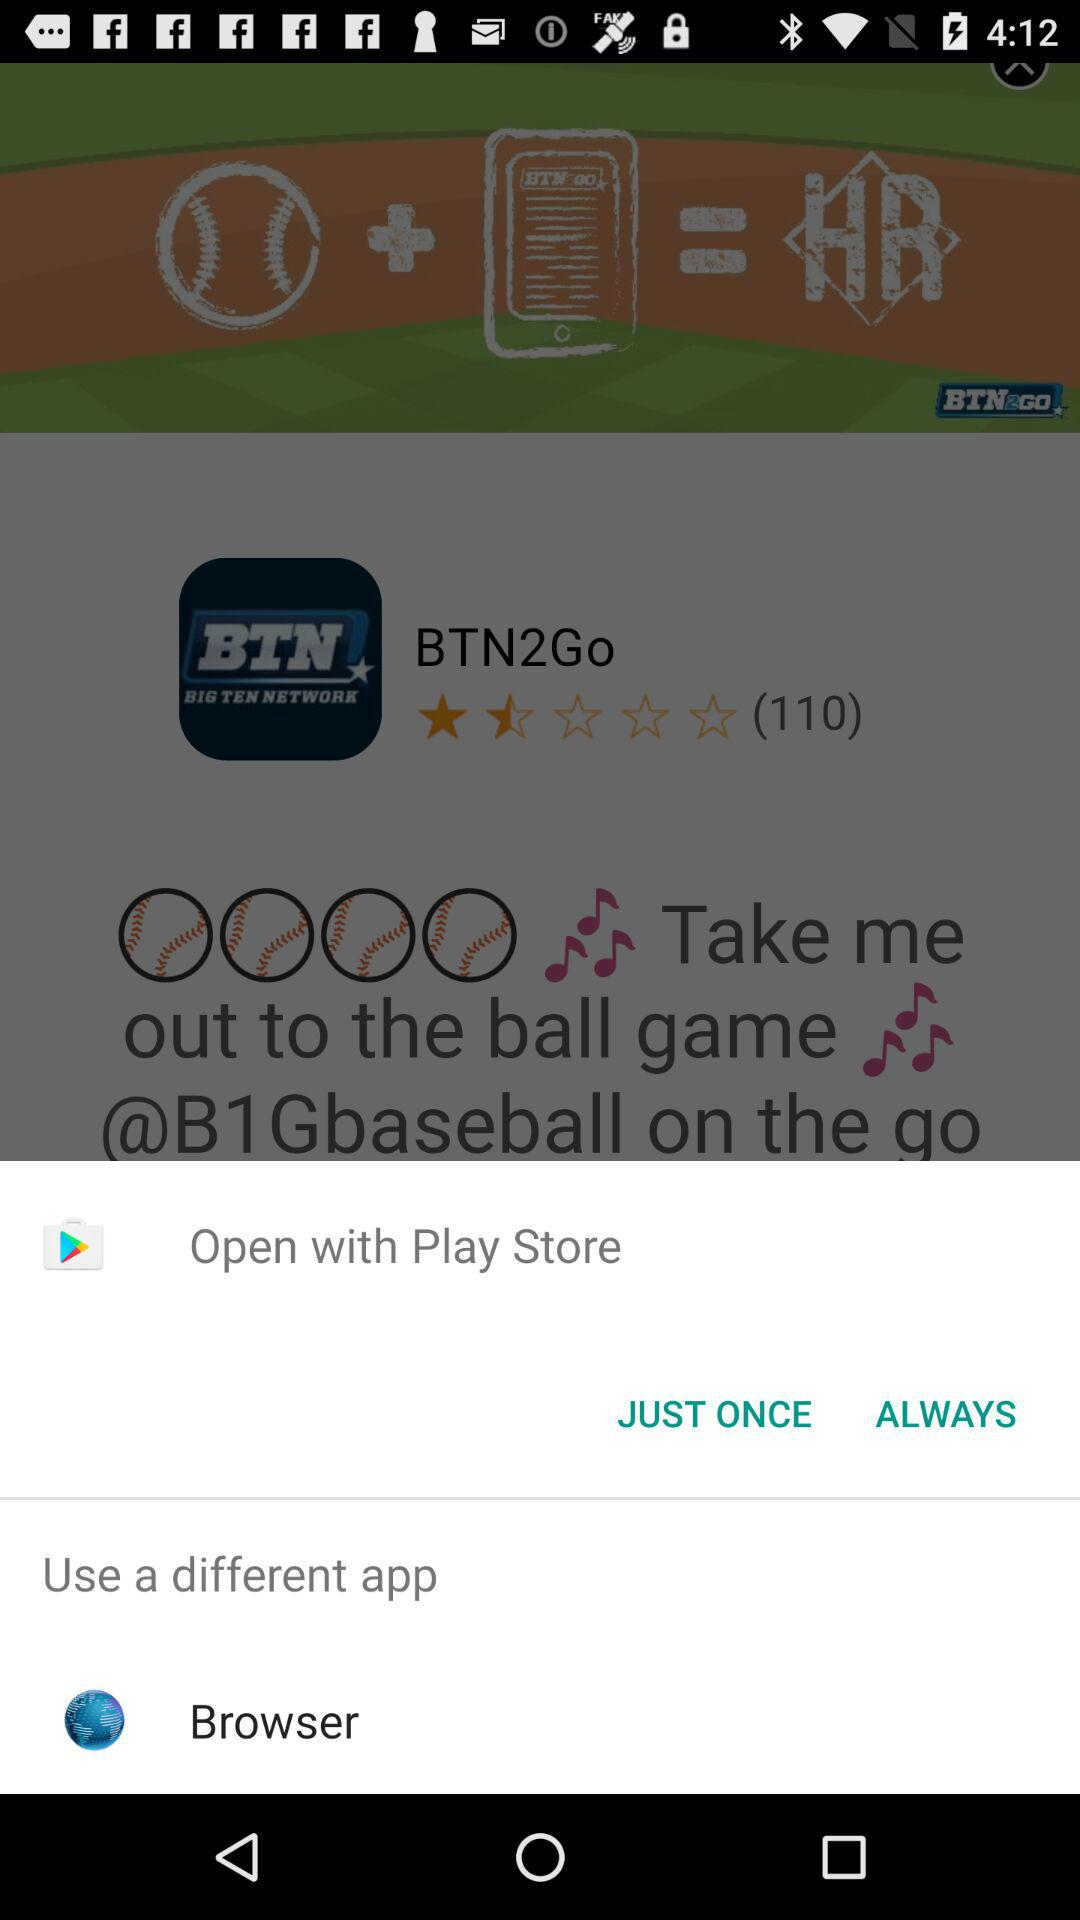What different app can I use? The different app that you can use is "Browser". 